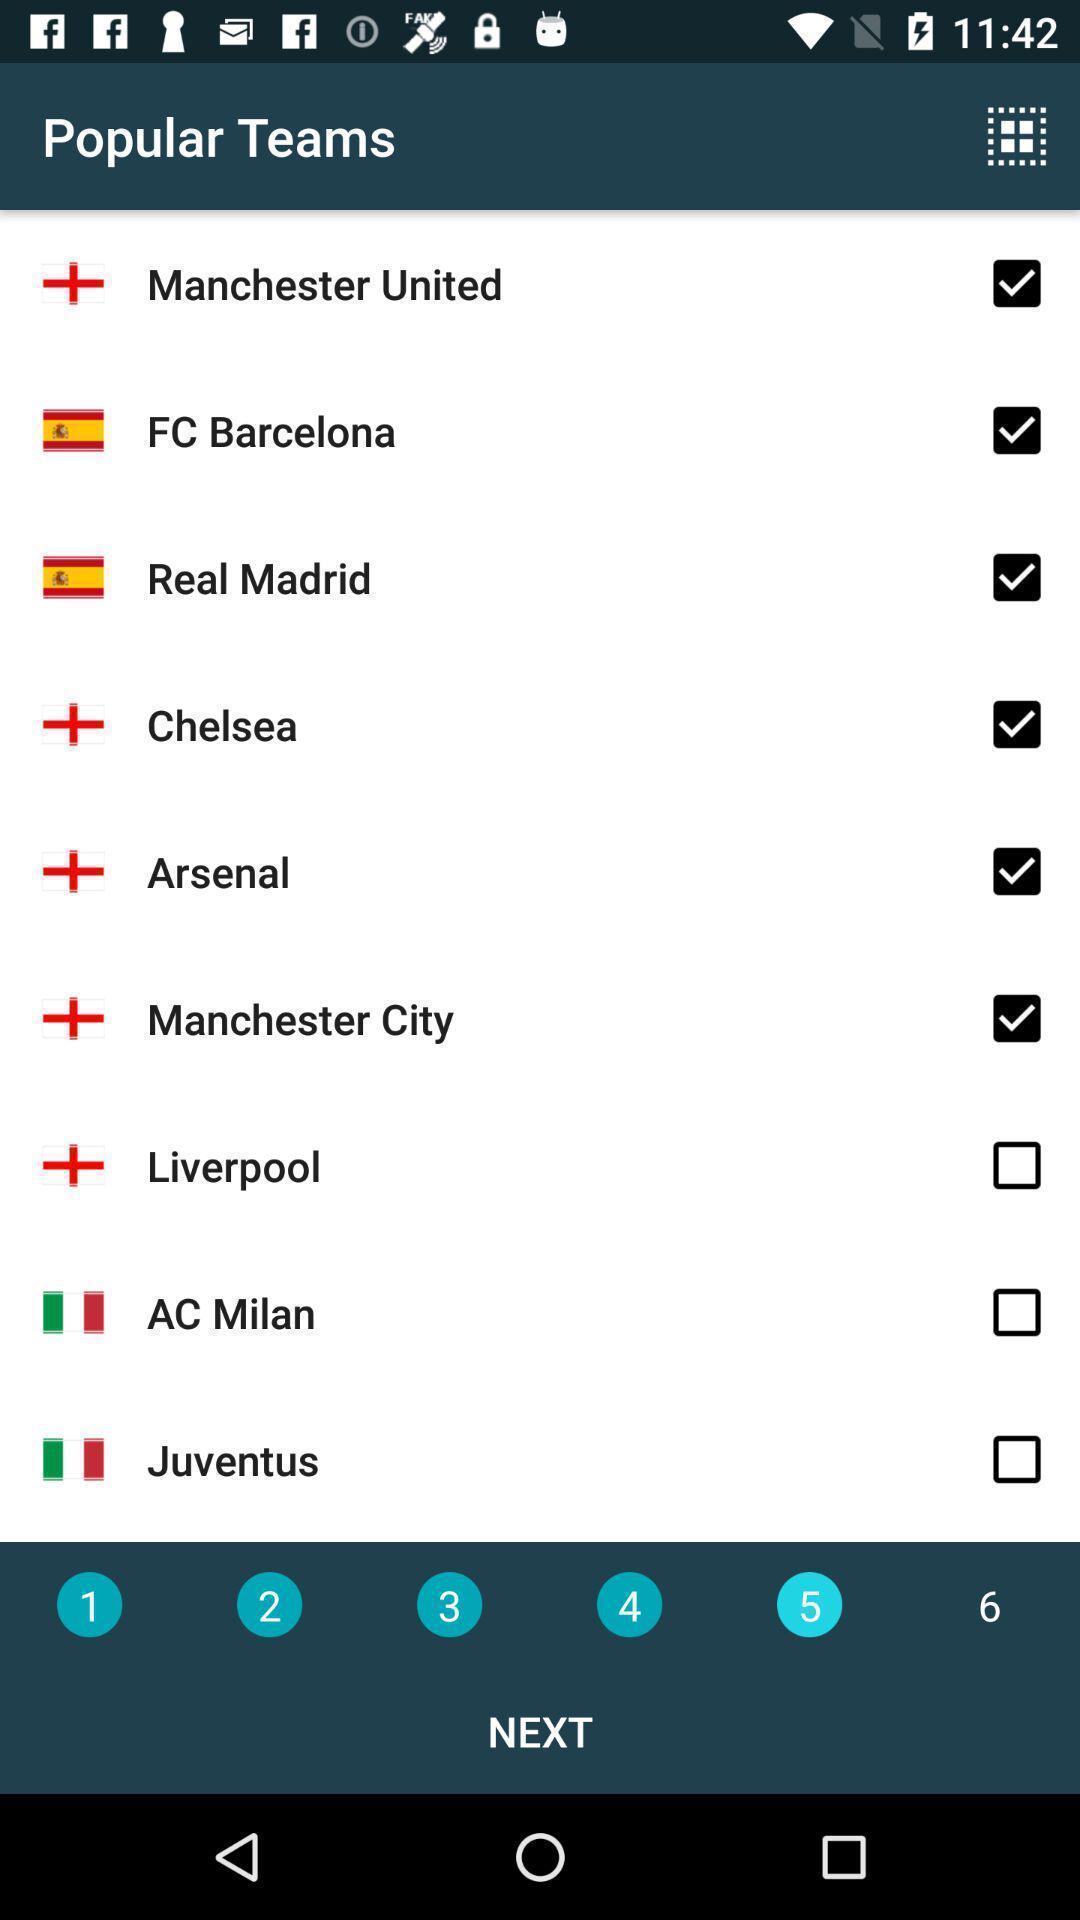Explain the elements present in this screenshot. Screen page displaying various options. 